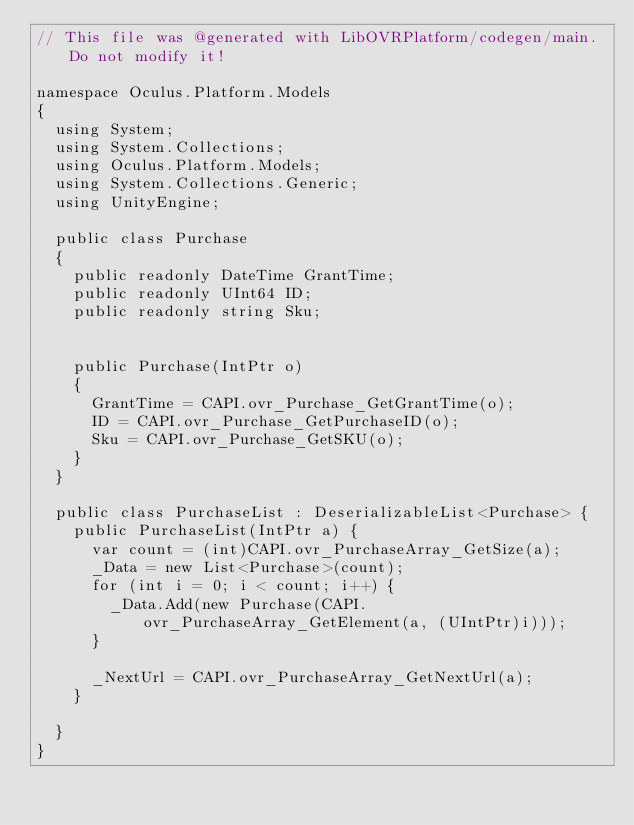Convert code to text. <code><loc_0><loc_0><loc_500><loc_500><_C#_>// This file was @generated with LibOVRPlatform/codegen/main. Do not modify it!

namespace Oculus.Platform.Models
{
  using System;
  using System.Collections;
  using Oculus.Platform.Models;
  using System.Collections.Generic;
  using UnityEngine;

  public class Purchase
  {
    public readonly DateTime GrantTime;
    public readonly UInt64 ID;
    public readonly string Sku;


    public Purchase(IntPtr o)
    {
      GrantTime = CAPI.ovr_Purchase_GetGrantTime(o);
      ID = CAPI.ovr_Purchase_GetPurchaseID(o);
      Sku = CAPI.ovr_Purchase_GetSKU(o);
    }
  }

  public class PurchaseList : DeserializableList<Purchase> {
    public PurchaseList(IntPtr a) {
      var count = (int)CAPI.ovr_PurchaseArray_GetSize(a);
      _Data = new List<Purchase>(count);
      for (int i = 0; i < count; i++) {
        _Data.Add(new Purchase(CAPI.ovr_PurchaseArray_GetElement(a, (UIntPtr)i)));
      }

      _NextUrl = CAPI.ovr_PurchaseArray_GetNextUrl(a);
    }

  }
}
</code> 